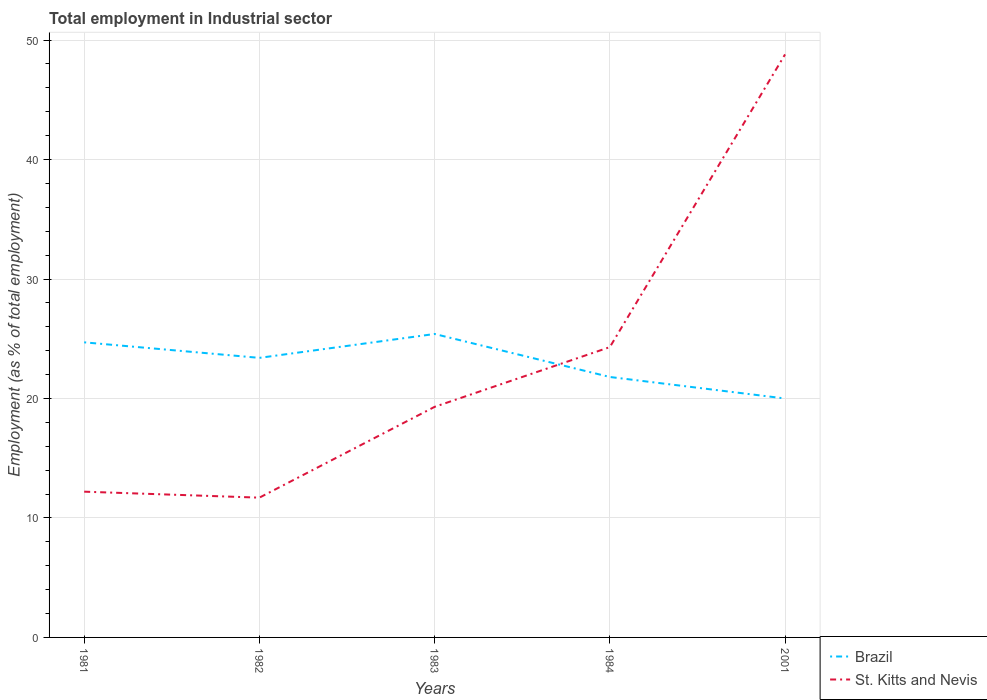How many different coloured lines are there?
Your answer should be compact. 2. Does the line corresponding to Brazil intersect with the line corresponding to St. Kitts and Nevis?
Make the answer very short. Yes. Is the number of lines equal to the number of legend labels?
Make the answer very short. Yes. What is the total employment in industrial sector in Brazil in the graph?
Keep it short and to the point. 2.9. What is the difference between the highest and the second highest employment in industrial sector in St. Kitts and Nevis?
Your response must be concise. 37.1. What is the difference between the highest and the lowest employment in industrial sector in Brazil?
Offer a very short reply. 3. Is the employment in industrial sector in St. Kitts and Nevis strictly greater than the employment in industrial sector in Brazil over the years?
Offer a very short reply. No. How many lines are there?
Ensure brevity in your answer.  2. How many years are there in the graph?
Offer a very short reply. 5. Does the graph contain grids?
Offer a very short reply. Yes. How many legend labels are there?
Give a very brief answer. 2. How are the legend labels stacked?
Make the answer very short. Vertical. What is the title of the graph?
Provide a succinct answer. Total employment in Industrial sector. What is the label or title of the Y-axis?
Offer a terse response. Employment (as % of total employment). What is the Employment (as % of total employment) of Brazil in 1981?
Your response must be concise. 24.7. What is the Employment (as % of total employment) of St. Kitts and Nevis in 1981?
Offer a terse response. 12.2. What is the Employment (as % of total employment) of Brazil in 1982?
Keep it short and to the point. 23.4. What is the Employment (as % of total employment) in St. Kitts and Nevis in 1982?
Offer a terse response. 11.7. What is the Employment (as % of total employment) of Brazil in 1983?
Your response must be concise. 25.4. What is the Employment (as % of total employment) in St. Kitts and Nevis in 1983?
Make the answer very short. 19.3. What is the Employment (as % of total employment) of Brazil in 1984?
Your answer should be compact. 21.8. What is the Employment (as % of total employment) in St. Kitts and Nevis in 1984?
Provide a succinct answer. 24.3. What is the Employment (as % of total employment) of St. Kitts and Nevis in 2001?
Your answer should be very brief. 48.8. Across all years, what is the maximum Employment (as % of total employment) in Brazil?
Provide a succinct answer. 25.4. Across all years, what is the maximum Employment (as % of total employment) in St. Kitts and Nevis?
Keep it short and to the point. 48.8. Across all years, what is the minimum Employment (as % of total employment) in St. Kitts and Nevis?
Offer a terse response. 11.7. What is the total Employment (as % of total employment) of Brazil in the graph?
Keep it short and to the point. 115.3. What is the total Employment (as % of total employment) of St. Kitts and Nevis in the graph?
Your answer should be very brief. 116.3. What is the difference between the Employment (as % of total employment) in St. Kitts and Nevis in 1981 and that in 1983?
Your answer should be compact. -7.1. What is the difference between the Employment (as % of total employment) of St. Kitts and Nevis in 1981 and that in 2001?
Provide a short and direct response. -36.6. What is the difference between the Employment (as % of total employment) of Brazil in 1982 and that in 1983?
Keep it short and to the point. -2. What is the difference between the Employment (as % of total employment) of St. Kitts and Nevis in 1982 and that in 1984?
Make the answer very short. -12.6. What is the difference between the Employment (as % of total employment) of Brazil in 1982 and that in 2001?
Provide a short and direct response. 3.4. What is the difference between the Employment (as % of total employment) in St. Kitts and Nevis in 1982 and that in 2001?
Make the answer very short. -37.1. What is the difference between the Employment (as % of total employment) in St. Kitts and Nevis in 1983 and that in 2001?
Ensure brevity in your answer.  -29.5. What is the difference between the Employment (as % of total employment) of St. Kitts and Nevis in 1984 and that in 2001?
Your answer should be very brief. -24.5. What is the difference between the Employment (as % of total employment) of Brazil in 1981 and the Employment (as % of total employment) of St. Kitts and Nevis in 1982?
Offer a terse response. 13. What is the difference between the Employment (as % of total employment) in Brazil in 1981 and the Employment (as % of total employment) in St. Kitts and Nevis in 1983?
Give a very brief answer. 5.4. What is the difference between the Employment (as % of total employment) of Brazil in 1981 and the Employment (as % of total employment) of St. Kitts and Nevis in 2001?
Offer a very short reply. -24.1. What is the difference between the Employment (as % of total employment) of Brazil in 1982 and the Employment (as % of total employment) of St. Kitts and Nevis in 1984?
Your answer should be compact. -0.9. What is the difference between the Employment (as % of total employment) of Brazil in 1982 and the Employment (as % of total employment) of St. Kitts and Nevis in 2001?
Provide a short and direct response. -25.4. What is the difference between the Employment (as % of total employment) in Brazil in 1983 and the Employment (as % of total employment) in St. Kitts and Nevis in 2001?
Your response must be concise. -23.4. What is the difference between the Employment (as % of total employment) in Brazil in 1984 and the Employment (as % of total employment) in St. Kitts and Nevis in 2001?
Keep it short and to the point. -27. What is the average Employment (as % of total employment) in Brazil per year?
Your answer should be very brief. 23.06. What is the average Employment (as % of total employment) of St. Kitts and Nevis per year?
Your answer should be compact. 23.26. In the year 2001, what is the difference between the Employment (as % of total employment) in Brazil and Employment (as % of total employment) in St. Kitts and Nevis?
Your response must be concise. -28.8. What is the ratio of the Employment (as % of total employment) of Brazil in 1981 to that in 1982?
Give a very brief answer. 1.06. What is the ratio of the Employment (as % of total employment) in St. Kitts and Nevis in 1981 to that in 1982?
Your answer should be very brief. 1.04. What is the ratio of the Employment (as % of total employment) in Brazil in 1981 to that in 1983?
Give a very brief answer. 0.97. What is the ratio of the Employment (as % of total employment) of St. Kitts and Nevis in 1981 to that in 1983?
Provide a short and direct response. 0.63. What is the ratio of the Employment (as % of total employment) of Brazil in 1981 to that in 1984?
Offer a terse response. 1.13. What is the ratio of the Employment (as % of total employment) of St. Kitts and Nevis in 1981 to that in 1984?
Offer a very short reply. 0.5. What is the ratio of the Employment (as % of total employment) of Brazil in 1981 to that in 2001?
Your response must be concise. 1.24. What is the ratio of the Employment (as % of total employment) of Brazil in 1982 to that in 1983?
Make the answer very short. 0.92. What is the ratio of the Employment (as % of total employment) of St. Kitts and Nevis in 1982 to that in 1983?
Keep it short and to the point. 0.61. What is the ratio of the Employment (as % of total employment) of Brazil in 1982 to that in 1984?
Keep it short and to the point. 1.07. What is the ratio of the Employment (as % of total employment) in St. Kitts and Nevis in 1982 to that in 1984?
Provide a short and direct response. 0.48. What is the ratio of the Employment (as % of total employment) in Brazil in 1982 to that in 2001?
Make the answer very short. 1.17. What is the ratio of the Employment (as % of total employment) in St. Kitts and Nevis in 1982 to that in 2001?
Your answer should be very brief. 0.24. What is the ratio of the Employment (as % of total employment) of Brazil in 1983 to that in 1984?
Your response must be concise. 1.17. What is the ratio of the Employment (as % of total employment) of St. Kitts and Nevis in 1983 to that in 1984?
Ensure brevity in your answer.  0.79. What is the ratio of the Employment (as % of total employment) of Brazil in 1983 to that in 2001?
Make the answer very short. 1.27. What is the ratio of the Employment (as % of total employment) in St. Kitts and Nevis in 1983 to that in 2001?
Offer a very short reply. 0.4. What is the ratio of the Employment (as % of total employment) of Brazil in 1984 to that in 2001?
Provide a succinct answer. 1.09. What is the ratio of the Employment (as % of total employment) in St. Kitts and Nevis in 1984 to that in 2001?
Offer a terse response. 0.5. What is the difference between the highest and the second highest Employment (as % of total employment) of Brazil?
Provide a short and direct response. 0.7. What is the difference between the highest and the lowest Employment (as % of total employment) of St. Kitts and Nevis?
Keep it short and to the point. 37.1. 